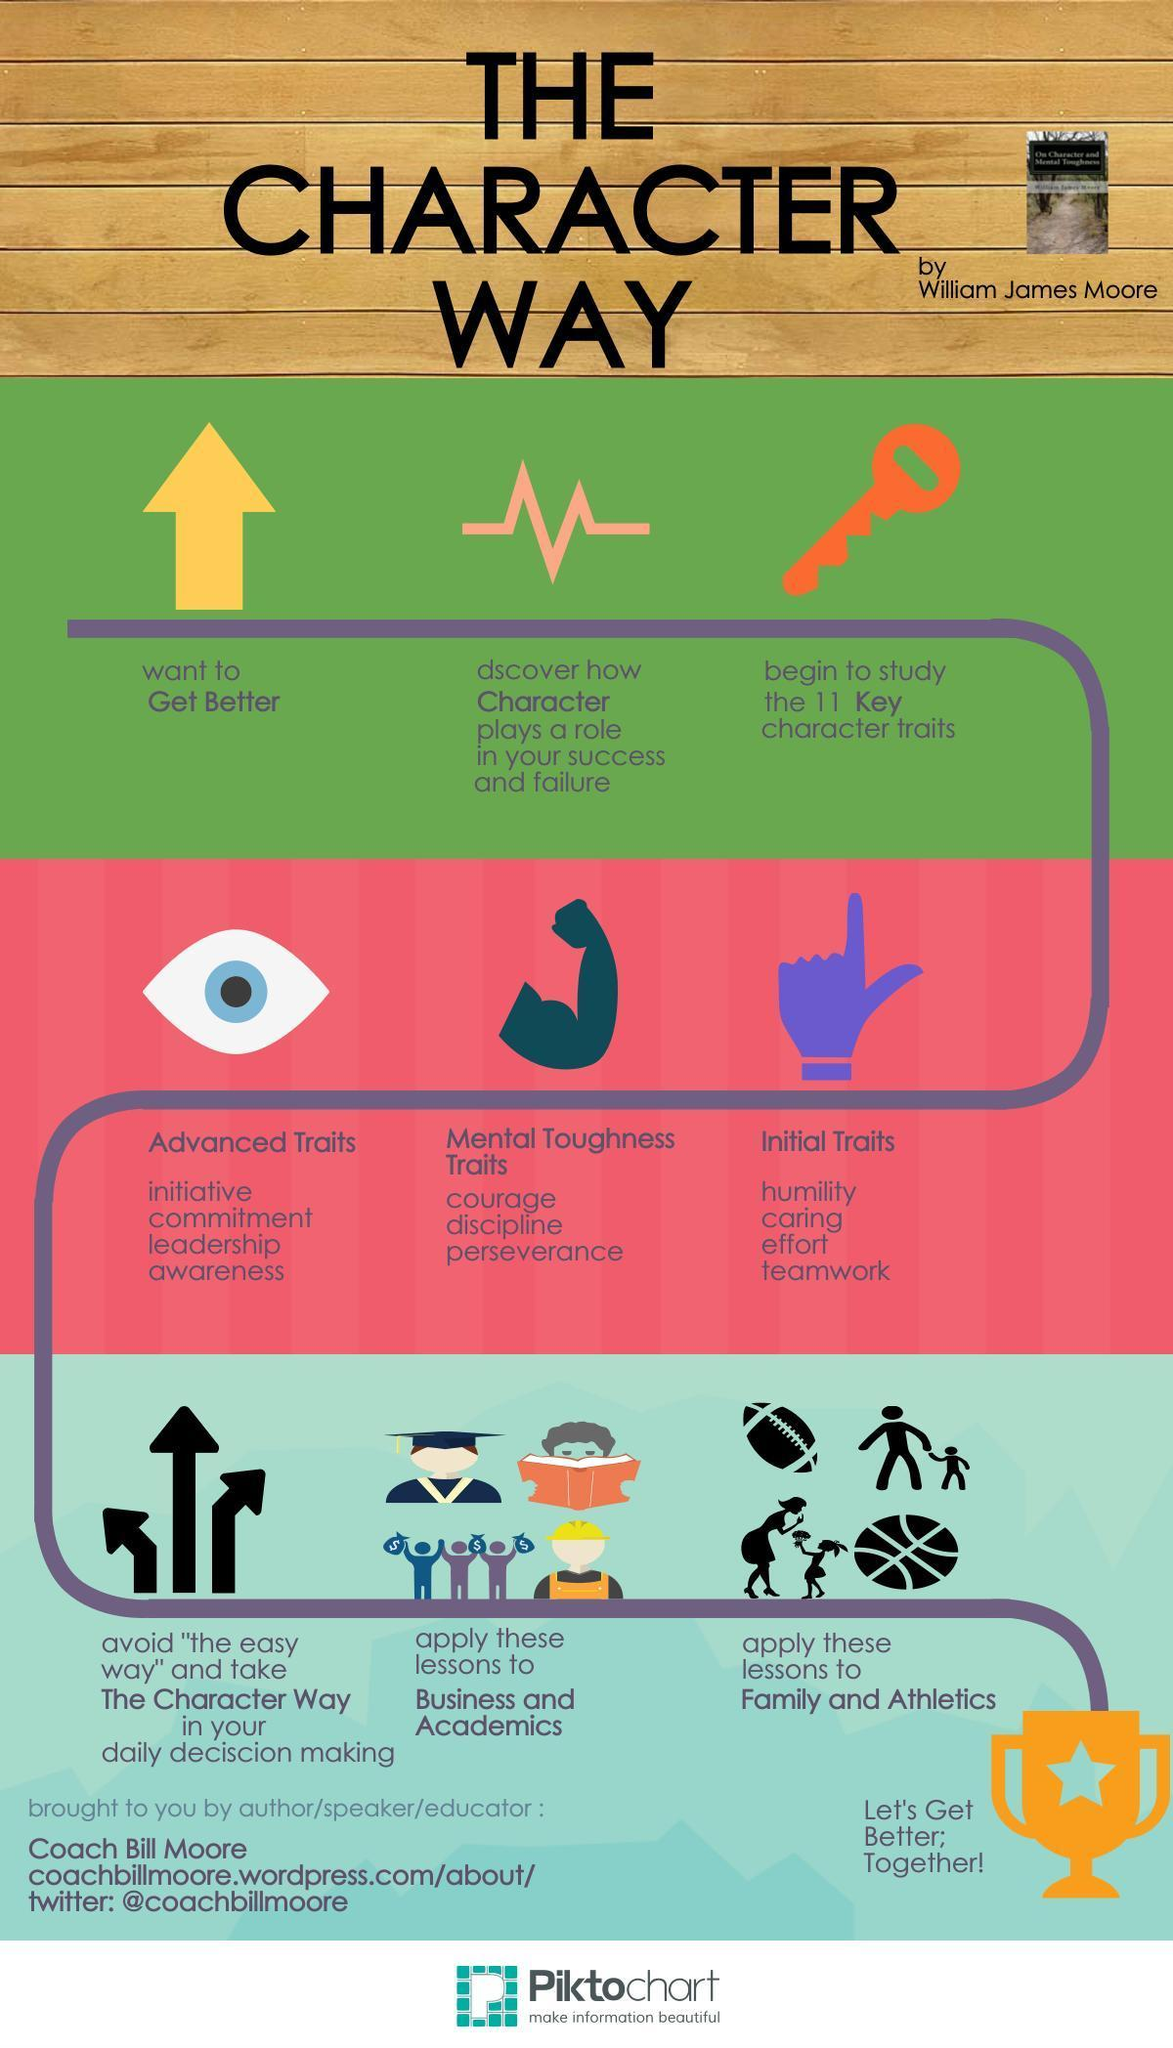How many arrows are in this infographic?
Answer the question with a short phrase. 4 